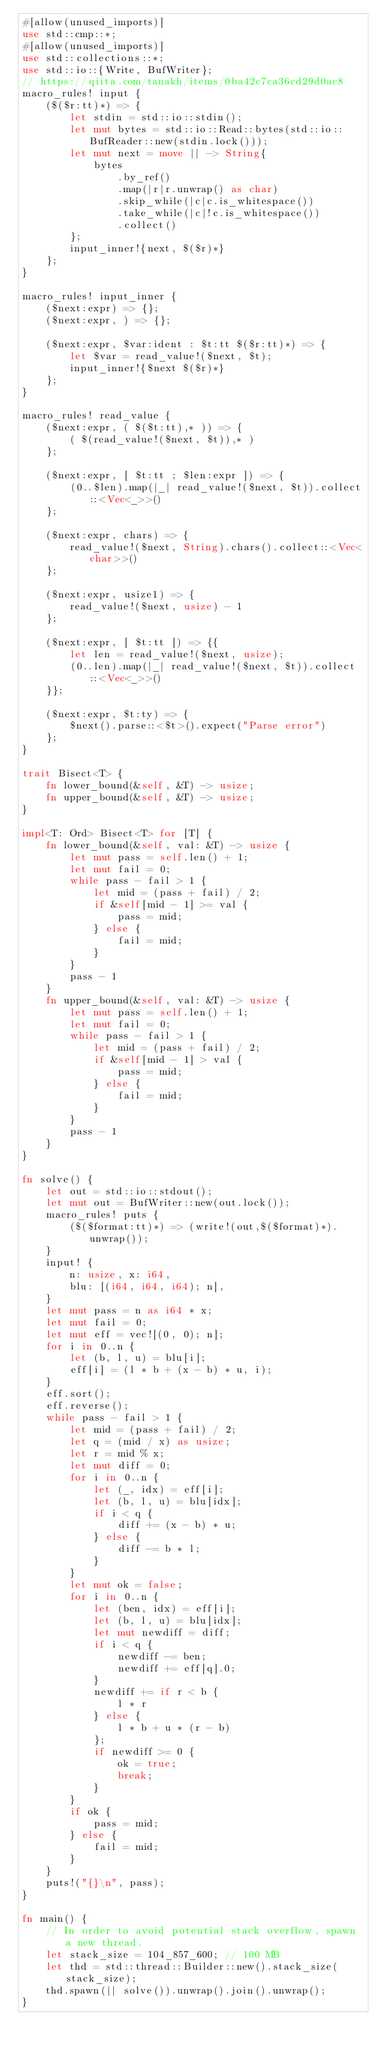<code> <loc_0><loc_0><loc_500><loc_500><_Rust_>#[allow(unused_imports)]
use std::cmp::*;
#[allow(unused_imports)]
use std::collections::*;
use std::io::{Write, BufWriter};
// https://qiita.com/tanakh/items/0ba42c7ca36cd29d0ac8
macro_rules! input {
    ($($r:tt)*) => {
        let stdin = std::io::stdin();
        let mut bytes = std::io::Read::bytes(std::io::BufReader::new(stdin.lock()));
        let mut next = move || -> String{
            bytes
                .by_ref()
                .map(|r|r.unwrap() as char)
                .skip_while(|c|c.is_whitespace())
                .take_while(|c|!c.is_whitespace())
                .collect()
        };
        input_inner!{next, $($r)*}
    };
}

macro_rules! input_inner {
    ($next:expr) => {};
    ($next:expr, ) => {};

    ($next:expr, $var:ident : $t:tt $($r:tt)*) => {
        let $var = read_value!($next, $t);
        input_inner!{$next $($r)*}
    };
}

macro_rules! read_value {
    ($next:expr, ( $($t:tt),* )) => {
        ( $(read_value!($next, $t)),* )
    };

    ($next:expr, [ $t:tt ; $len:expr ]) => {
        (0..$len).map(|_| read_value!($next, $t)).collect::<Vec<_>>()
    };

    ($next:expr, chars) => {
        read_value!($next, String).chars().collect::<Vec<char>>()
    };

    ($next:expr, usize1) => {
        read_value!($next, usize) - 1
    };

    ($next:expr, [ $t:tt ]) => {{
        let len = read_value!($next, usize);
        (0..len).map(|_| read_value!($next, $t)).collect::<Vec<_>>()
    }};

    ($next:expr, $t:ty) => {
        $next().parse::<$t>().expect("Parse error")
    };
}

trait Bisect<T> {
    fn lower_bound(&self, &T) -> usize;
    fn upper_bound(&self, &T) -> usize;
}

impl<T: Ord> Bisect<T> for [T] {
    fn lower_bound(&self, val: &T) -> usize {
        let mut pass = self.len() + 1;
        let mut fail = 0;
        while pass - fail > 1 {
            let mid = (pass + fail) / 2;
            if &self[mid - 1] >= val {
                pass = mid;
            } else {
                fail = mid;
            }
        }
        pass - 1
    }
    fn upper_bound(&self, val: &T) -> usize {
        let mut pass = self.len() + 1;
        let mut fail = 0;
        while pass - fail > 1 {
            let mid = (pass + fail) / 2;
            if &self[mid - 1] > val {
                pass = mid;
            } else {
                fail = mid;
            }
        }
        pass - 1
    }
}

fn solve() {
    let out = std::io::stdout();
    let mut out = BufWriter::new(out.lock());
    macro_rules! puts {
        ($($format:tt)*) => (write!(out,$($format)*).unwrap());
    }
    input! {
        n: usize, x: i64,
        blu: [(i64, i64, i64); n],
    }
    let mut pass = n as i64 * x;
    let mut fail = 0;
    let mut eff = vec![(0, 0); n];
    for i in 0..n {
        let (b, l, u) = blu[i];
        eff[i] = (l * b + (x - b) * u, i);
    }
    eff.sort();
    eff.reverse();
    while pass - fail > 1 {
        let mid = (pass + fail) / 2;
        let q = (mid / x) as usize;
        let r = mid % x;
        let mut diff = 0;
        for i in 0..n {
            let (_, idx) = eff[i];
            let (b, l, u) = blu[idx];
            if i < q {
                diff += (x - b) * u;
            } else {
                diff -= b * l;
            }
        }
        let mut ok = false;
        for i in 0..n {
            let (ben, idx) = eff[i];
            let (b, l, u) = blu[idx];
            let mut newdiff = diff;
            if i < q {
                newdiff -= ben;
                newdiff += eff[q].0;
            }
            newdiff += if r < b {
                l * r
            } else {
                l * b + u * (r - b)
            };
            if newdiff >= 0 {
                ok = true;
                break;
            }
        }
        if ok {
            pass = mid;
        } else {
            fail = mid;
        }
    }
    puts!("{}\n", pass);
}

fn main() {
    // In order to avoid potential stack overflow, spawn a new thread.
    let stack_size = 104_857_600; // 100 MB
    let thd = std::thread::Builder::new().stack_size(stack_size);
    thd.spawn(|| solve()).unwrap().join().unwrap();
}
</code> 